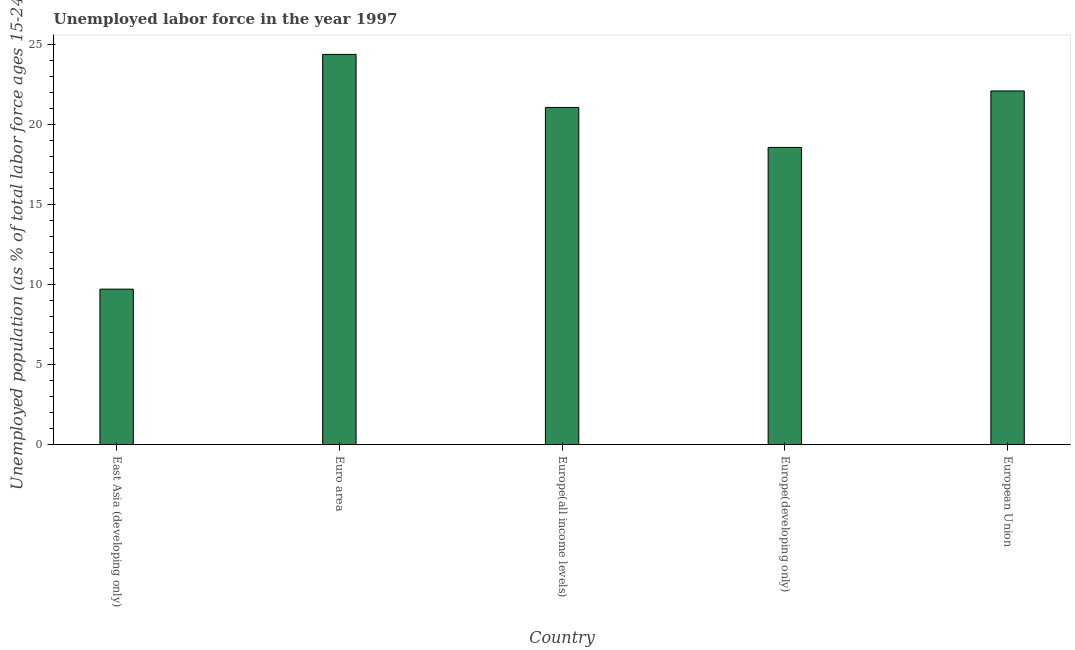Does the graph contain any zero values?
Provide a succinct answer. No. What is the title of the graph?
Provide a succinct answer. Unemployed labor force in the year 1997. What is the label or title of the X-axis?
Provide a short and direct response. Country. What is the label or title of the Y-axis?
Your answer should be very brief. Unemployed population (as % of total labor force ages 15-24). What is the total unemployed youth population in East Asia (developing only)?
Give a very brief answer. 9.72. Across all countries, what is the maximum total unemployed youth population?
Ensure brevity in your answer.  24.38. Across all countries, what is the minimum total unemployed youth population?
Your answer should be very brief. 9.72. In which country was the total unemployed youth population maximum?
Make the answer very short. Euro area. In which country was the total unemployed youth population minimum?
Your response must be concise. East Asia (developing only). What is the sum of the total unemployed youth population?
Your answer should be very brief. 95.84. What is the difference between the total unemployed youth population in East Asia (developing only) and Euro area?
Your answer should be very brief. -14.66. What is the average total unemployed youth population per country?
Provide a short and direct response. 19.17. What is the median total unemployed youth population?
Make the answer very short. 21.07. What is the ratio of the total unemployed youth population in East Asia (developing only) to that in Europe(developing only)?
Your response must be concise. 0.52. What is the difference between the highest and the second highest total unemployed youth population?
Provide a succinct answer. 2.28. Is the sum of the total unemployed youth population in Europe(all income levels) and Europe(developing only) greater than the maximum total unemployed youth population across all countries?
Give a very brief answer. Yes. What is the difference between the highest and the lowest total unemployed youth population?
Your answer should be compact. 14.66. Are all the bars in the graph horizontal?
Keep it short and to the point. No. How many countries are there in the graph?
Provide a succinct answer. 5. What is the difference between two consecutive major ticks on the Y-axis?
Give a very brief answer. 5. What is the Unemployed population (as % of total labor force ages 15-24) of East Asia (developing only)?
Make the answer very short. 9.72. What is the Unemployed population (as % of total labor force ages 15-24) of Euro area?
Ensure brevity in your answer.  24.38. What is the Unemployed population (as % of total labor force ages 15-24) in Europe(all income levels)?
Your answer should be very brief. 21.07. What is the Unemployed population (as % of total labor force ages 15-24) of Europe(developing only)?
Your answer should be compact. 18.57. What is the Unemployed population (as % of total labor force ages 15-24) in European Union?
Keep it short and to the point. 22.1. What is the difference between the Unemployed population (as % of total labor force ages 15-24) in East Asia (developing only) and Euro area?
Your answer should be very brief. -14.66. What is the difference between the Unemployed population (as % of total labor force ages 15-24) in East Asia (developing only) and Europe(all income levels)?
Ensure brevity in your answer.  -11.35. What is the difference between the Unemployed population (as % of total labor force ages 15-24) in East Asia (developing only) and Europe(developing only)?
Make the answer very short. -8.85. What is the difference between the Unemployed population (as % of total labor force ages 15-24) in East Asia (developing only) and European Union?
Your response must be concise. -12.38. What is the difference between the Unemployed population (as % of total labor force ages 15-24) in Euro area and Europe(all income levels)?
Offer a terse response. 3.31. What is the difference between the Unemployed population (as % of total labor force ages 15-24) in Euro area and Europe(developing only)?
Provide a short and direct response. 5.81. What is the difference between the Unemployed population (as % of total labor force ages 15-24) in Euro area and European Union?
Offer a terse response. 2.28. What is the difference between the Unemployed population (as % of total labor force ages 15-24) in Europe(all income levels) and Europe(developing only)?
Your answer should be compact. 2.5. What is the difference between the Unemployed population (as % of total labor force ages 15-24) in Europe(all income levels) and European Union?
Offer a very short reply. -1.03. What is the difference between the Unemployed population (as % of total labor force ages 15-24) in Europe(developing only) and European Union?
Offer a very short reply. -3.53. What is the ratio of the Unemployed population (as % of total labor force ages 15-24) in East Asia (developing only) to that in Euro area?
Provide a short and direct response. 0.4. What is the ratio of the Unemployed population (as % of total labor force ages 15-24) in East Asia (developing only) to that in Europe(all income levels)?
Give a very brief answer. 0.46. What is the ratio of the Unemployed population (as % of total labor force ages 15-24) in East Asia (developing only) to that in Europe(developing only)?
Keep it short and to the point. 0.52. What is the ratio of the Unemployed population (as % of total labor force ages 15-24) in East Asia (developing only) to that in European Union?
Provide a short and direct response. 0.44. What is the ratio of the Unemployed population (as % of total labor force ages 15-24) in Euro area to that in Europe(all income levels)?
Provide a succinct answer. 1.16. What is the ratio of the Unemployed population (as % of total labor force ages 15-24) in Euro area to that in Europe(developing only)?
Your answer should be compact. 1.31. What is the ratio of the Unemployed population (as % of total labor force ages 15-24) in Euro area to that in European Union?
Give a very brief answer. 1.1. What is the ratio of the Unemployed population (as % of total labor force ages 15-24) in Europe(all income levels) to that in Europe(developing only)?
Offer a very short reply. 1.13. What is the ratio of the Unemployed population (as % of total labor force ages 15-24) in Europe(all income levels) to that in European Union?
Ensure brevity in your answer.  0.95. What is the ratio of the Unemployed population (as % of total labor force ages 15-24) in Europe(developing only) to that in European Union?
Offer a very short reply. 0.84. 